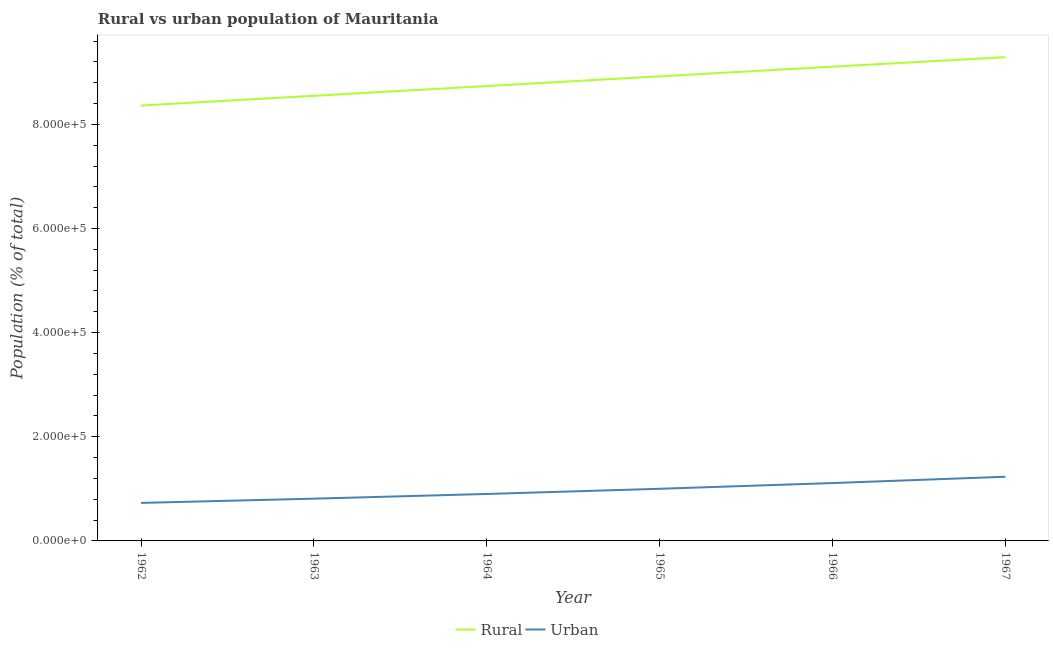Does the line corresponding to urban population density intersect with the line corresponding to rural population density?
Provide a short and direct response. No. Is the number of lines equal to the number of legend labels?
Provide a succinct answer. Yes. What is the urban population density in 1965?
Make the answer very short. 1.00e+05. Across all years, what is the maximum rural population density?
Keep it short and to the point. 9.29e+05. Across all years, what is the minimum rural population density?
Give a very brief answer. 8.36e+05. In which year was the rural population density maximum?
Provide a succinct answer. 1967. In which year was the rural population density minimum?
Ensure brevity in your answer.  1962. What is the total urban population density in the graph?
Give a very brief answer. 5.79e+05. What is the difference between the rural population density in 1965 and that in 1967?
Your answer should be compact. -3.68e+04. What is the difference between the urban population density in 1967 and the rural population density in 1965?
Provide a succinct answer. -7.69e+05. What is the average rural population density per year?
Your answer should be very brief. 8.83e+05. In the year 1967, what is the difference between the urban population density and rural population density?
Keep it short and to the point. -8.06e+05. What is the ratio of the rural population density in 1964 to that in 1965?
Give a very brief answer. 0.98. Is the urban population density in 1965 less than that in 1967?
Your answer should be compact. Yes. What is the difference between the highest and the second highest urban population density?
Give a very brief answer. 1.21e+04. What is the difference between the highest and the lowest rural population density?
Your response must be concise. 9.29e+04. Is the urban population density strictly greater than the rural population density over the years?
Your response must be concise. No. Is the urban population density strictly less than the rural population density over the years?
Your response must be concise. Yes. How many lines are there?
Your answer should be very brief. 2. How many years are there in the graph?
Provide a succinct answer. 6. What is the difference between two consecutive major ticks on the Y-axis?
Provide a short and direct response. 2.00e+05. How many legend labels are there?
Keep it short and to the point. 2. What is the title of the graph?
Provide a succinct answer. Rural vs urban population of Mauritania. Does "Drinking water services" appear as one of the legend labels in the graph?
Your response must be concise. No. What is the label or title of the X-axis?
Keep it short and to the point. Year. What is the label or title of the Y-axis?
Give a very brief answer. Population (% of total). What is the Population (% of total) of Rural in 1962?
Provide a short and direct response. 8.36e+05. What is the Population (% of total) in Urban in 1962?
Ensure brevity in your answer.  7.30e+04. What is the Population (% of total) in Rural in 1963?
Your response must be concise. 8.55e+05. What is the Population (% of total) in Urban in 1963?
Give a very brief answer. 8.12e+04. What is the Population (% of total) in Rural in 1964?
Offer a very short reply. 8.74e+05. What is the Population (% of total) in Urban in 1964?
Give a very brief answer. 9.02e+04. What is the Population (% of total) of Rural in 1965?
Your response must be concise. 8.92e+05. What is the Population (% of total) of Urban in 1965?
Provide a short and direct response. 1.00e+05. What is the Population (% of total) in Rural in 1966?
Offer a terse response. 9.11e+05. What is the Population (% of total) of Urban in 1966?
Offer a very short reply. 1.11e+05. What is the Population (% of total) in Rural in 1967?
Make the answer very short. 9.29e+05. What is the Population (% of total) of Urban in 1967?
Make the answer very short. 1.23e+05. Across all years, what is the maximum Population (% of total) of Rural?
Make the answer very short. 9.29e+05. Across all years, what is the maximum Population (% of total) in Urban?
Your response must be concise. 1.23e+05. Across all years, what is the minimum Population (% of total) of Rural?
Offer a terse response. 8.36e+05. Across all years, what is the minimum Population (% of total) in Urban?
Give a very brief answer. 7.30e+04. What is the total Population (% of total) of Rural in the graph?
Give a very brief answer. 5.30e+06. What is the total Population (% of total) in Urban in the graph?
Your response must be concise. 5.79e+05. What is the difference between the Population (% of total) in Rural in 1962 and that in 1963?
Your answer should be very brief. -1.87e+04. What is the difference between the Population (% of total) in Urban in 1962 and that in 1963?
Your answer should be compact. -8146. What is the difference between the Population (% of total) in Rural in 1962 and that in 1964?
Ensure brevity in your answer.  -3.74e+04. What is the difference between the Population (% of total) of Urban in 1962 and that in 1964?
Make the answer very short. -1.72e+04. What is the difference between the Population (% of total) of Rural in 1962 and that in 1965?
Ensure brevity in your answer.  -5.61e+04. What is the difference between the Population (% of total) in Urban in 1962 and that in 1965?
Make the answer very short. -2.71e+04. What is the difference between the Population (% of total) in Rural in 1962 and that in 1966?
Provide a short and direct response. -7.46e+04. What is the difference between the Population (% of total) in Urban in 1962 and that in 1966?
Provide a succinct answer. -3.81e+04. What is the difference between the Population (% of total) in Rural in 1962 and that in 1967?
Provide a succinct answer. -9.29e+04. What is the difference between the Population (% of total) in Urban in 1962 and that in 1967?
Your answer should be compact. -5.02e+04. What is the difference between the Population (% of total) in Rural in 1963 and that in 1964?
Provide a short and direct response. -1.87e+04. What is the difference between the Population (% of total) of Urban in 1963 and that in 1964?
Give a very brief answer. -9016. What is the difference between the Population (% of total) of Rural in 1963 and that in 1965?
Your response must be concise. -3.74e+04. What is the difference between the Population (% of total) in Urban in 1963 and that in 1965?
Make the answer very short. -1.90e+04. What is the difference between the Population (% of total) in Rural in 1963 and that in 1966?
Keep it short and to the point. -5.59e+04. What is the difference between the Population (% of total) in Urban in 1963 and that in 1966?
Keep it short and to the point. -3.00e+04. What is the difference between the Population (% of total) in Rural in 1963 and that in 1967?
Your answer should be very brief. -7.42e+04. What is the difference between the Population (% of total) in Urban in 1963 and that in 1967?
Keep it short and to the point. -4.21e+04. What is the difference between the Population (% of total) of Rural in 1964 and that in 1965?
Ensure brevity in your answer.  -1.87e+04. What is the difference between the Population (% of total) of Urban in 1964 and that in 1965?
Ensure brevity in your answer.  -9952. What is the difference between the Population (% of total) of Rural in 1964 and that in 1966?
Provide a succinct answer. -3.72e+04. What is the difference between the Population (% of total) in Urban in 1964 and that in 1966?
Offer a very short reply. -2.09e+04. What is the difference between the Population (% of total) of Rural in 1964 and that in 1967?
Keep it short and to the point. -5.55e+04. What is the difference between the Population (% of total) in Urban in 1964 and that in 1967?
Offer a very short reply. -3.31e+04. What is the difference between the Population (% of total) of Rural in 1965 and that in 1966?
Ensure brevity in your answer.  -1.85e+04. What is the difference between the Population (% of total) in Urban in 1965 and that in 1966?
Offer a very short reply. -1.10e+04. What is the difference between the Population (% of total) in Rural in 1965 and that in 1967?
Your answer should be very brief. -3.68e+04. What is the difference between the Population (% of total) in Urban in 1965 and that in 1967?
Ensure brevity in your answer.  -2.31e+04. What is the difference between the Population (% of total) of Rural in 1966 and that in 1967?
Provide a short and direct response. -1.83e+04. What is the difference between the Population (% of total) in Urban in 1966 and that in 1967?
Keep it short and to the point. -1.21e+04. What is the difference between the Population (% of total) in Rural in 1962 and the Population (% of total) in Urban in 1963?
Keep it short and to the point. 7.55e+05. What is the difference between the Population (% of total) of Rural in 1962 and the Population (% of total) of Urban in 1964?
Keep it short and to the point. 7.46e+05. What is the difference between the Population (% of total) in Rural in 1962 and the Population (% of total) in Urban in 1965?
Ensure brevity in your answer.  7.36e+05. What is the difference between the Population (% of total) of Rural in 1962 and the Population (% of total) of Urban in 1966?
Offer a terse response. 7.25e+05. What is the difference between the Population (% of total) in Rural in 1962 and the Population (% of total) in Urban in 1967?
Keep it short and to the point. 7.13e+05. What is the difference between the Population (% of total) in Rural in 1963 and the Population (% of total) in Urban in 1964?
Provide a short and direct response. 7.65e+05. What is the difference between the Population (% of total) in Rural in 1963 and the Population (% of total) in Urban in 1965?
Offer a terse response. 7.55e+05. What is the difference between the Population (% of total) of Rural in 1963 and the Population (% of total) of Urban in 1966?
Give a very brief answer. 7.44e+05. What is the difference between the Population (% of total) in Rural in 1963 and the Population (% of total) in Urban in 1967?
Offer a terse response. 7.32e+05. What is the difference between the Population (% of total) in Rural in 1964 and the Population (% of total) in Urban in 1965?
Offer a terse response. 7.73e+05. What is the difference between the Population (% of total) of Rural in 1964 and the Population (% of total) of Urban in 1966?
Your answer should be very brief. 7.62e+05. What is the difference between the Population (% of total) in Rural in 1964 and the Population (% of total) in Urban in 1967?
Your answer should be very brief. 7.50e+05. What is the difference between the Population (% of total) in Rural in 1965 and the Population (% of total) in Urban in 1966?
Provide a succinct answer. 7.81e+05. What is the difference between the Population (% of total) of Rural in 1965 and the Population (% of total) of Urban in 1967?
Offer a terse response. 7.69e+05. What is the difference between the Population (% of total) in Rural in 1966 and the Population (% of total) in Urban in 1967?
Keep it short and to the point. 7.88e+05. What is the average Population (% of total) of Rural per year?
Ensure brevity in your answer.  8.83e+05. What is the average Population (% of total) of Urban per year?
Offer a very short reply. 9.65e+04. In the year 1962, what is the difference between the Population (% of total) of Rural and Population (% of total) of Urban?
Ensure brevity in your answer.  7.63e+05. In the year 1963, what is the difference between the Population (% of total) in Rural and Population (% of total) in Urban?
Keep it short and to the point. 7.74e+05. In the year 1964, what is the difference between the Population (% of total) in Rural and Population (% of total) in Urban?
Offer a very short reply. 7.83e+05. In the year 1965, what is the difference between the Population (% of total) in Rural and Population (% of total) in Urban?
Your answer should be very brief. 7.92e+05. In the year 1966, what is the difference between the Population (% of total) in Rural and Population (% of total) in Urban?
Your answer should be very brief. 8.00e+05. In the year 1967, what is the difference between the Population (% of total) of Rural and Population (% of total) of Urban?
Offer a terse response. 8.06e+05. What is the ratio of the Population (% of total) in Rural in 1962 to that in 1963?
Your answer should be very brief. 0.98. What is the ratio of the Population (% of total) of Urban in 1962 to that in 1963?
Ensure brevity in your answer.  0.9. What is the ratio of the Population (% of total) of Rural in 1962 to that in 1964?
Make the answer very short. 0.96. What is the ratio of the Population (% of total) in Urban in 1962 to that in 1964?
Your answer should be compact. 0.81. What is the ratio of the Population (% of total) in Rural in 1962 to that in 1965?
Provide a short and direct response. 0.94. What is the ratio of the Population (% of total) of Urban in 1962 to that in 1965?
Offer a terse response. 0.73. What is the ratio of the Population (% of total) in Rural in 1962 to that in 1966?
Offer a very short reply. 0.92. What is the ratio of the Population (% of total) of Urban in 1962 to that in 1966?
Give a very brief answer. 0.66. What is the ratio of the Population (% of total) in Rural in 1962 to that in 1967?
Make the answer very short. 0.9. What is the ratio of the Population (% of total) in Urban in 1962 to that in 1967?
Your response must be concise. 0.59. What is the ratio of the Population (% of total) in Rural in 1963 to that in 1964?
Provide a succinct answer. 0.98. What is the ratio of the Population (% of total) of Urban in 1963 to that in 1964?
Keep it short and to the point. 0.9. What is the ratio of the Population (% of total) of Rural in 1963 to that in 1965?
Your answer should be compact. 0.96. What is the ratio of the Population (% of total) in Urban in 1963 to that in 1965?
Provide a short and direct response. 0.81. What is the ratio of the Population (% of total) in Rural in 1963 to that in 1966?
Offer a terse response. 0.94. What is the ratio of the Population (% of total) of Urban in 1963 to that in 1966?
Make the answer very short. 0.73. What is the ratio of the Population (% of total) in Rural in 1963 to that in 1967?
Ensure brevity in your answer.  0.92. What is the ratio of the Population (% of total) of Urban in 1963 to that in 1967?
Your response must be concise. 0.66. What is the ratio of the Population (% of total) of Rural in 1964 to that in 1965?
Your answer should be very brief. 0.98. What is the ratio of the Population (% of total) in Urban in 1964 to that in 1965?
Make the answer very short. 0.9. What is the ratio of the Population (% of total) of Rural in 1964 to that in 1966?
Offer a very short reply. 0.96. What is the ratio of the Population (% of total) in Urban in 1964 to that in 1966?
Provide a short and direct response. 0.81. What is the ratio of the Population (% of total) of Rural in 1964 to that in 1967?
Your response must be concise. 0.94. What is the ratio of the Population (% of total) in Urban in 1964 to that in 1967?
Provide a short and direct response. 0.73. What is the ratio of the Population (% of total) of Rural in 1965 to that in 1966?
Give a very brief answer. 0.98. What is the ratio of the Population (% of total) in Urban in 1965 to that in 1966?
Offer a very short reply. 0.9. What is the ratio of the Population (% of total) in Rural in 1965 to that in 1967?
Keep it short and to the point. 0.96. What is the ratio of the Population (% of total) in Urban in 1965 to that in 1967?
Your answer should be compact. 0.81. What is the ratio of the Population (% of total) of Rural in 1966 to that in 1967?
Ensure brevity in your answer.  0.98. What is the ratio of the Population (% of total) of Urban in 1966 to that in 1967?
Make the answer very short. 0.9. What is the difference between the highest and the second highest Population (% of total) in Rural?
Your response must be concise. 1.83e+04. What is the difference between the highest and the second highest Population (% of total) of Urban?
Make the answer very short. 1.21e+04. What is the difference between the highest and the lowest Population (% of total) in Rural?
Ensure brevity in your answer.  9.29e+04. What is the difference between the highest and the lowest Population (% of total) in Urban?
Offer a very short reply. 5.02e+04. 